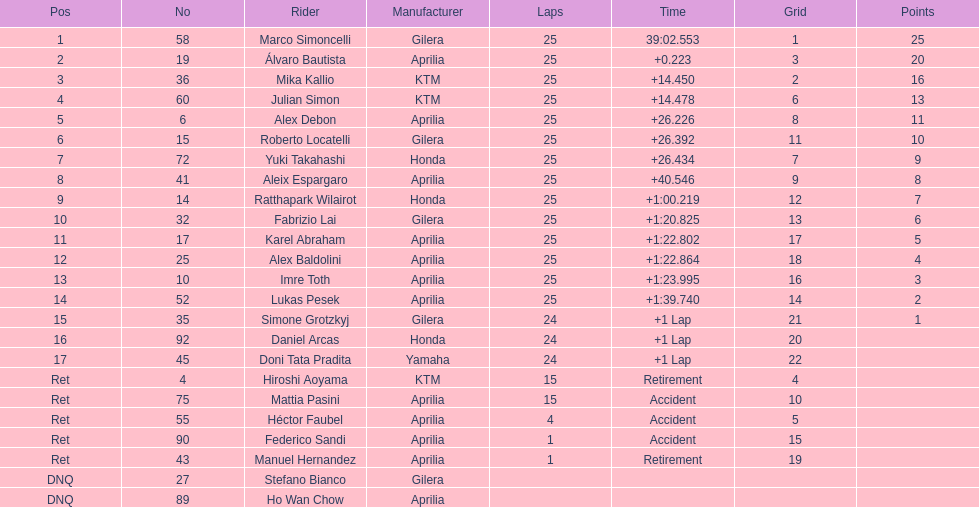The subsequent italian rider besides champion marco simoncelli was Roberto Locatelli. 